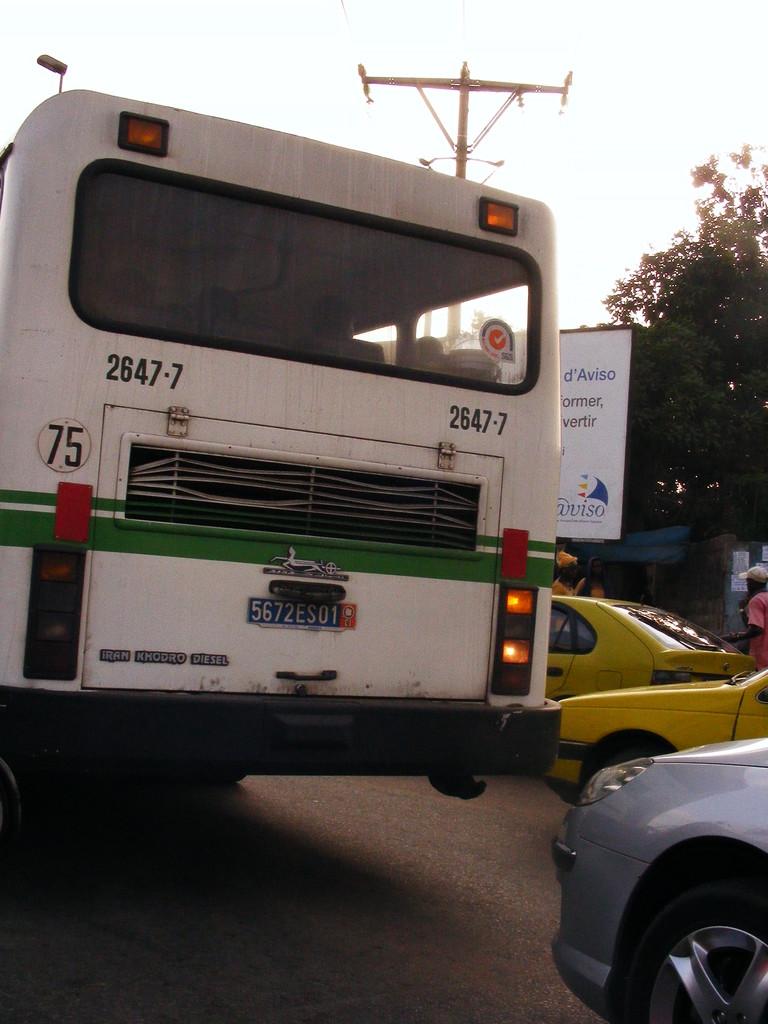What number bus is the white bus?
Make the answer very short. 2647-7. How many people that bus can carry at a time?
Offer a very short reply. Unanswerable. 